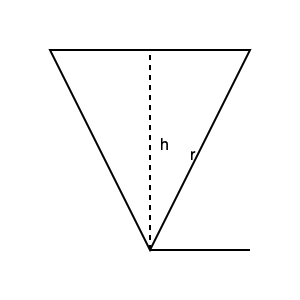A cone has a radius of $5$ cm and a height of $12$ cm. Calculate the volume of this cone. (Use $\pi = 3.14$ and round your answer to the nearest cubic centimeter.) Let's approach this step-by-step:

1) The formula for the volume of a cone is:

   $$ V = \frac{1}{3}\pi r^2 h $$

   Where $V$ is volume, $r$ is radius, and $h$ is height.

2) We're given:
   - Radius $(r) = 5$ cm
   - Height $(h) = 12$ cm
   - $\pi = 3.14$

3) Let's substitute these values into our formula:

   $$ V = \frac{1}{3} \times 3.14 \times 5^2 \times 12 $$

4) Let's solve step by step:
   - First, calculate $5^2 = 25$
   $$ V = \frac{1}{3} \times 3.14 \times 25 \times 12 $$

   - Multiply the numbers:
   $$ V = \frac{1}{3} \times 942 $$

   - Divide:
   $$ V = 314 $$

5) Rounding to the nearest cubic centimeter:

   The volume is 314 cubic centimeters.
Answer: 314 cm³ 